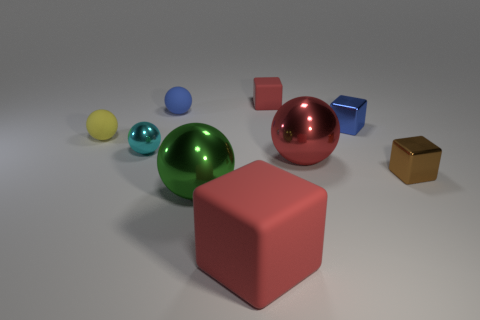Subtract all brown blocks. How many blocks are left? 3 Add 1 big blue metallic cylinders. How many objects exist? 10 Subtract 1 blocks. How many blocks are left? 3 Subtract all blue balls. How many balls are left? 4 Subtract all balls. How many objects are left? 4 Subtract all blue balls. Subtract all green blocks. How many balls are left? 4 Subtract all cyan balls. How many red cubes are left? 2 Subtract all large brown cylinders. Subtract all yellow matte spheres. How many objects are left? 8 Add 4 cyan shiny things. How many cyan shiny things are left? 5 Add 5 tiny blue blocks. How many tiny blue blocks exist? 6 